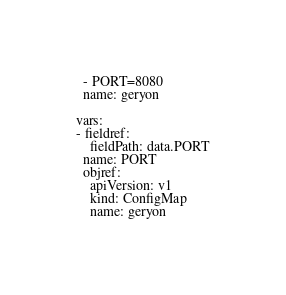<code> <loc_0><loc_0><loc_500><loc_500><_YAML_>  - PORT=8080
  name: geryon

vars:
- fieldref:
    fieldPath: data.PORT
  name: PORT
  objref:
    apiVersion: v1
    kind: ConfigMap
    name: geryon
</code> 